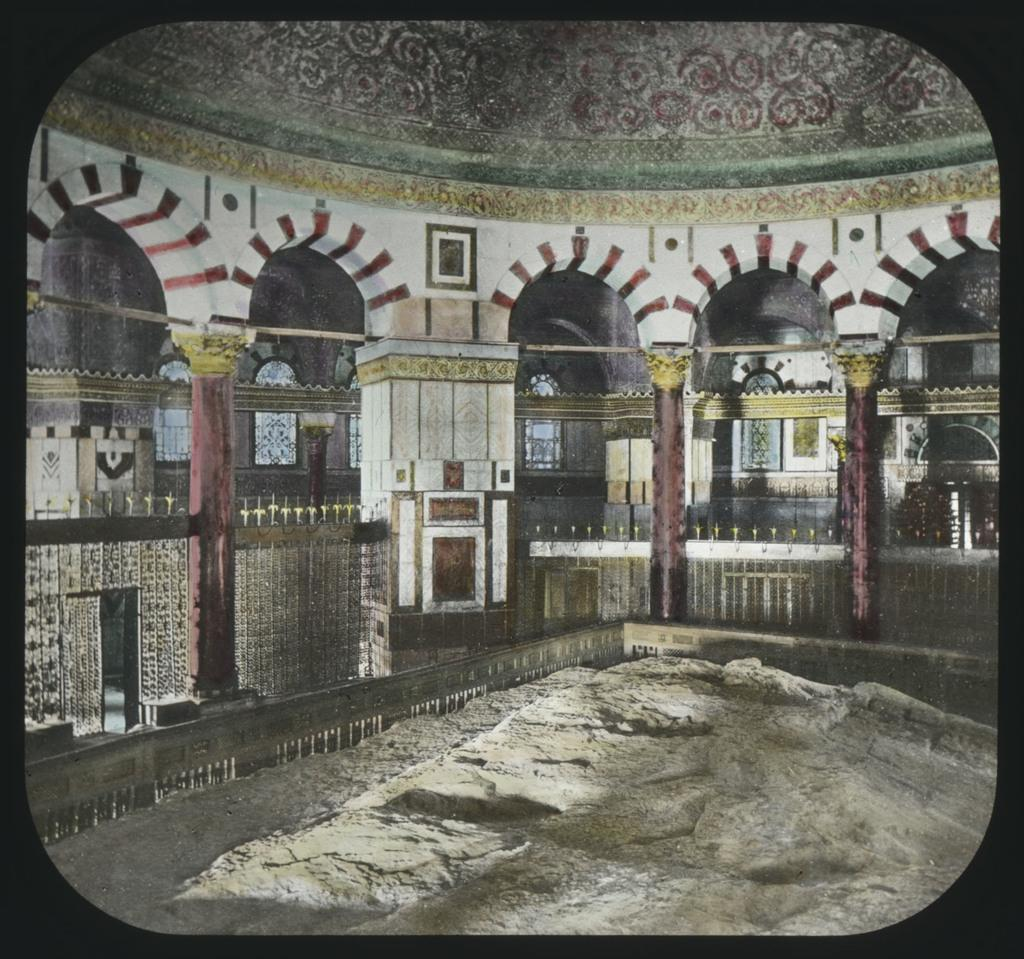What type of location is depicted in the image? The image shows an inside view of a building. What architectural features can be seen in the building? There are windows and pillars in the building. What is the bottom of the image composed of? The bottom of the image contains sand. What type of sack is being used as a caption for the image? There is no sack or caption present in the image. How does the rainstorm affect the building in the image? There is no rainstorm depicted in the image; it shows an inside view of a building with windows and pillars. 